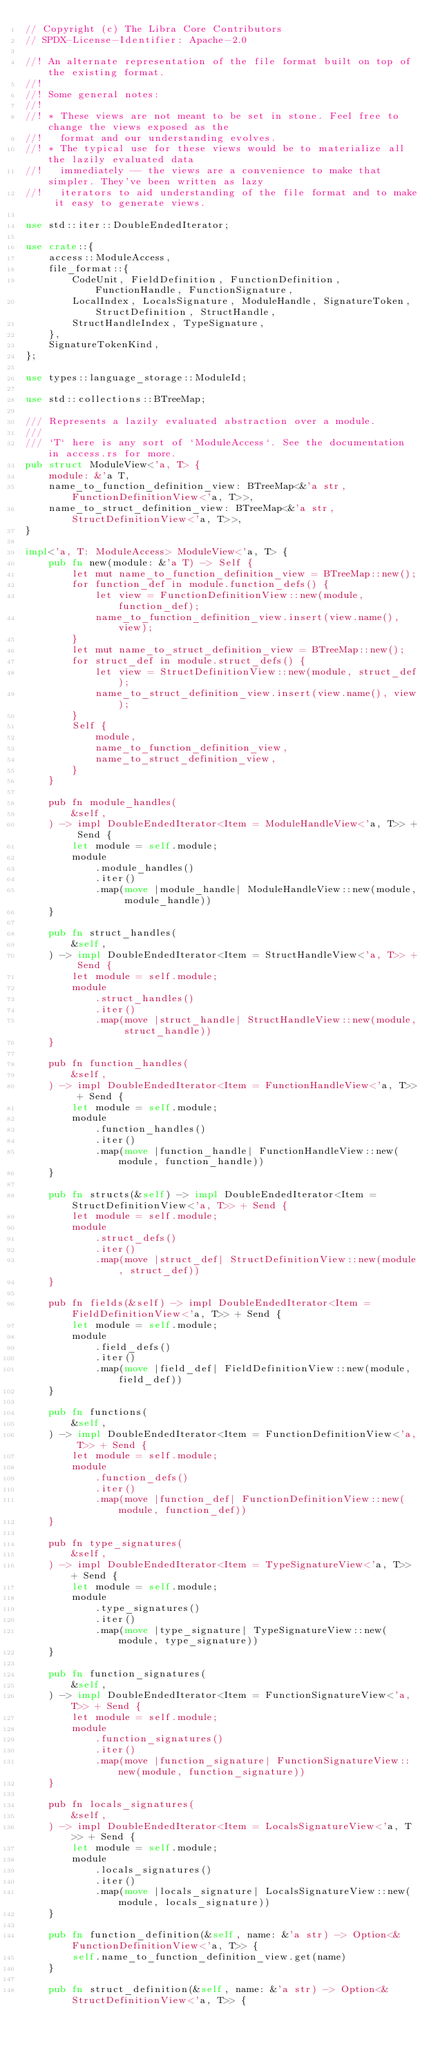Convert code to text. <code><loc_0><loc_0><loc_500><loc_500><_Rust_>// Copyright (c) The Libra Core Contributors
// SPDX-License-Identifier: Apache-2.0

//! An alternate representation of the file format built on top of the existing format.
//!
//! Some general notes:
//!
//! * These views are not meant to be set in stone. Feel free to change the views exposed as the
//!   format and our understanding evolves.
//! * The typical use for these views would be to materialize all the lazily evaluated data
//!   immediately -- the views are a convenience to make that simpler. They've been written as lazy
//!   iterators to aid understanding of the file format and to make it easy to generate views.

use std::iter::DoubleEndedIterator;

use crate::{
    access::ModuleAccess,
    file_format::{
        CodeUnit, FieldDefinition, FunctionDefinition, FunctionHandle, FunctionSignature,
        LocalIndex, LocalsSignature, ModuleHandle, SignatureToken, StructDefinition, StructHandle,
        StructHandleIndex, TypeSignature,
    },
    SignatureTokenKind,
};

use types::language_storage::ModuleId;

use std::collections::BTreeMap;

/// Represents a lazily evaluated abstraction over a module.
///
/// `T` here is any sort of `ModuleAccess`. See the documentation in access.rs for more.
pub struct ModuleView<'a, T> {
    module: &'a T,
    name_to_function_definition_view: BTreeMap<&'a str, FunctionDefinitionView<'a, T>>,
    name_to_struct_definition_view: BTreeMap<&'a str, StructDefinitionView<'a, T>>,
}

impl<'a, T: ModuleAccess> ModuleView<'a, T> {
    pub fn new(module: &'a T) -> Self {
        let mut name_to_function_definition_view = BTreeMap::new();
        for function_def in module.function_defs() {
            let view = FunctionDefinitionView::new(module, function_def);
            name_to_function_definition_view.insert(view.name(), view);
        }
        let mut name_to_struct_definition_view = BTreeMap::new();
        for struct_def in module.struct_defs() {
            let view = StructDefinitionView::new(module, struct_def);
            name_to_struct_definition_view.insert(view.name(), view);
        }
        Self {
            module,
            name_to_function_definition_view,
            name_to_struct_definition_view,
        }
    }

    pub fn module_handles(
        &self,
    ) -> impl DoubleEndedIterator<Item = ModuleHandleView<'a, T>> + Send {
        let module = self.module;
        module
            .module_handles()
            .iter()
            .map(move |module_handle| ModuleHandleView::new(module, module_handle))
    }

    pub fn struct_handles(
        &self,
    ) -> impl DoubleEndedIterator<Item = StructHandleView<'a, T>> + Send {
        let module = self.module;
        module
            .struct_handles()
            .iter()
            .map(move |struct_handle| StructHandleView::new(module, struct_handle))
    }

    pub fn function_handles(
        &self,
    ) -> impl DoubleEndedIterator<Item = FunctionHandleView<'a, T>> + Send {
        let module = self.module;
        module
            .function_handles()
            .iter()
            .map(move |function_handle| FunctionHandleView::new(module, function_handle))
    }

    pub fn structs(&self) -> impl DoubleEndedIterator<Item = StructDefinitionView<'a, T>> + Send {
        let module = self.module;
        module
            .struct_defs()
            .iter()
            .map(move |struct_def| StructDefinitionView::new(module, struct_def))
    }

    pub fn fields(&self) -> impl DoubleEndedIterator<Item = FieldDefinitionView<'a, T>> + Send {
        let module = self.module;
        module
            .field_defs()
            .iter()
            .map(move |field_def| FieldDefinitionView::new(module, field_def))
    }

    pub fn functions(
        &self,
    ) -> impl DoubleEndedIterator<Item = FunctionDefinitionView<'a, T>> + Send {
        let module = self.module;
        module
            .function_defs()
            .iter()
            .map(move |function_def| FunctionDefinitionView::new(module, function_def))
    }

    pub fn type_signatures(
        &self,
    ) -> impl DoubleEndedIterator<Item = TypeSignatureView<'a, T>> + Send {
        let module = self.module;
        module
            .type_signatures()
            .iter()
            .map(move |type_signature| TypeSignatureView::new(module, type_signature))
    }

    pub fn function_signatures(
        &self,
    ) -> impl DoubleEndedIterator<Item = FunctionSignatureView<'a, T>> + Send {
        let module = self.module;
        module
            .function_signatures()
            .iter()
            .map(move |function_signature| FunctionSignatureView::new(module, function_signature))
    }

    pub fn locals_signatures(
        &self,
    ) -> impl DoubleEndedIterator<Item = LocalsSignatureView<'a, T>> + Send {
        let module = self.module;
        module
            .locals_signatures()
            .iter()
            .map(move |locals_signature| LocalsSignatureView::new(module, locals_signature))
    }

    pub fn function_definition(&self, name: &'a str) -> Option<&FunctionDefinitionView<'a, T>> {
        self.name_to_function_definition_view.get(name)
    }

    pub fn struct_definition(&self, name: &'a str) -> Option<&StructDefinitionView<'a, T>> {</code> 